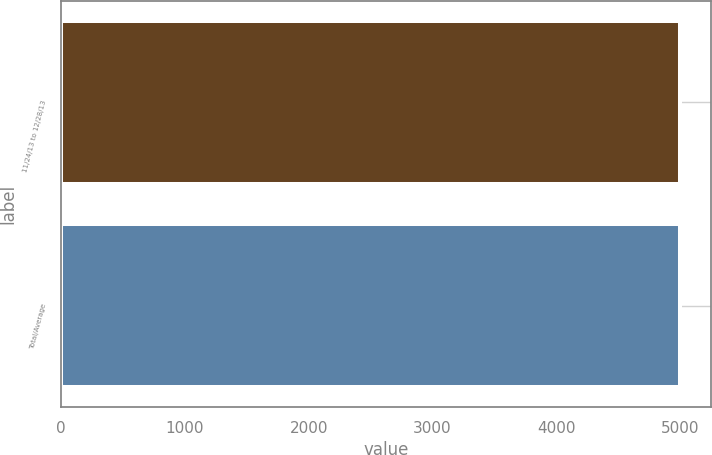Convert chart to OTSL. <chart><loc_0><loc_0><loc_500><loc_500><bar_chart><fcel>11/24/13 to 12/28/13<fcel>Total/Average<nl><fcel>5000<fcel>5000.1<nl></chart> 